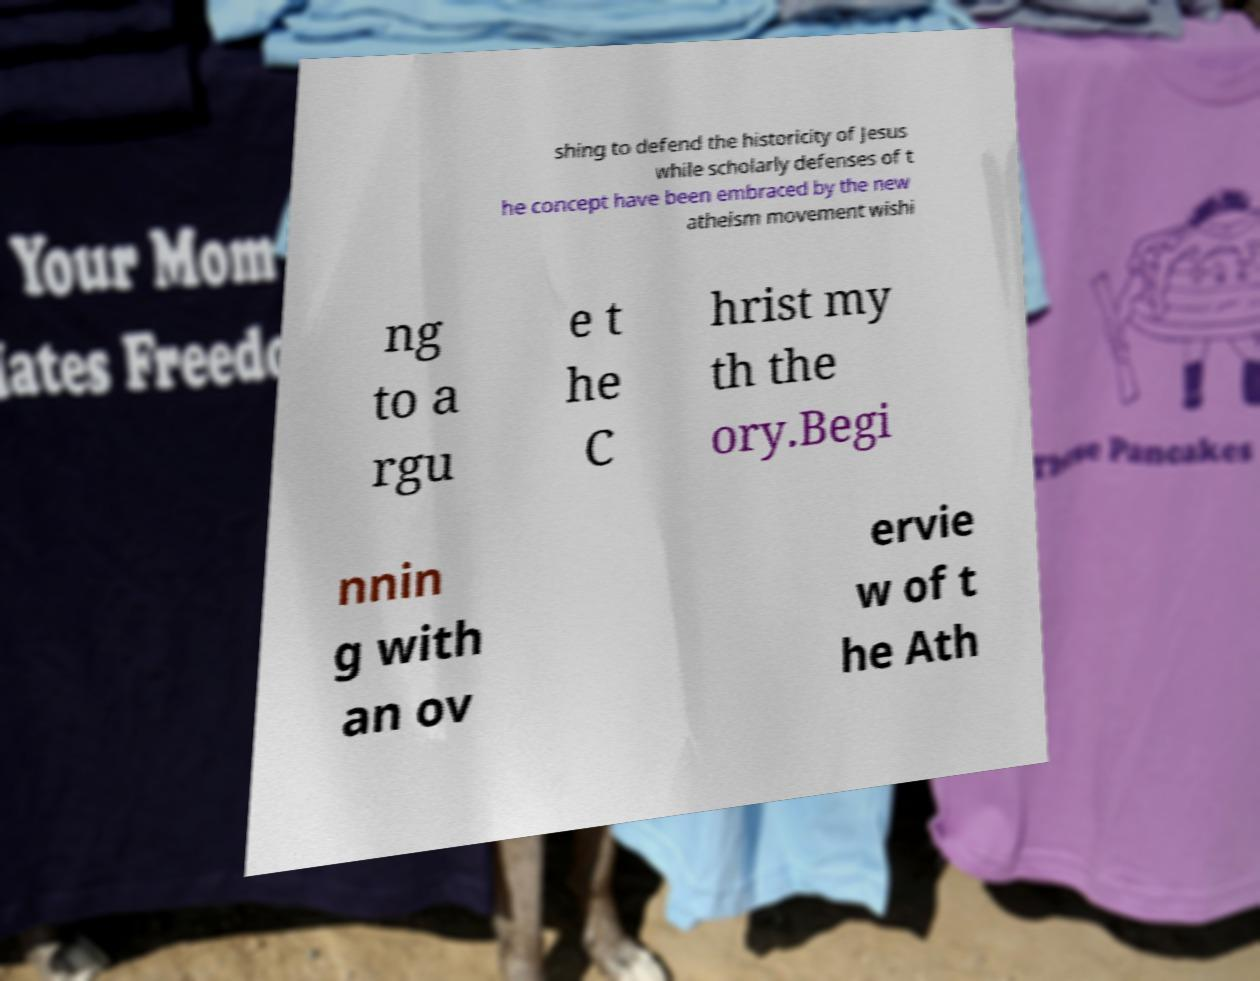What messages or text are displayed in this image? I need them in a readable, typed format. shing to defend the historicity of Jesus while scholarly defenses of t he concept have been embraced by the new atheism movement wishi ng to a rgu e t he C hrist my th the ory.Begi nnin g with an ov ervie w of t he Ath 